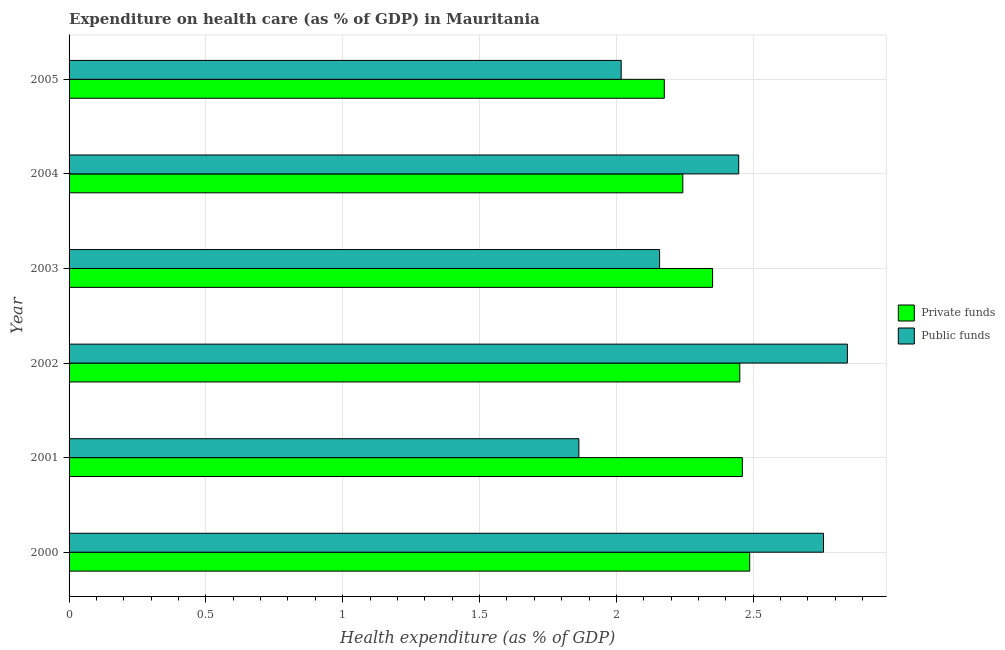How many groups of bars are there?
Your answer should be compact. 6. Are the number of bars per tick equal to the number of legend labels?
Provide a succinct answer. Yes. What is the amount of private funds spent in healthcare in 2003?
Offer a very short reply. 2.35. Across all years, what is the maximum amount of private funds spent in healthcare?
Offer a very short reply. 2.49. Across all years, what is the minimum amount of private funds spent in healthcare?
Your answer should be compact. 2.18. In which year was the amount of private funds spent in healthcare maximum?
Your response must be concise. 2000. What is the total amount of private funds spent in healthcare in the graph?
Your answer should be compact. 14.17. What is the difference between the amount of public funds spent in healthcare in 2000 and that in 2005?
Keep it short and to the point. 0.74. What is the difference between the amount of public funds spent in healthcare in 2004 and the amount of private funds spent in healthcare in 2001?
Provide a short and direct response. -0.01. What is the average amount of public funds spent in healthcare per year?
Offer a terse response. 2.35. In the year 2001, what is the difference between the amount of private funds spent in healthcare and amount of public funds spent in healthcare?
Your answer should be compact. 0.6. What is the ratio of the amount of public funds spent in healthcare in 2001 to that in 2002?
Offer a very short reply. 0.66. Is the amount of private funds spent in healthcare in 2000 less than that in 2001?
Give a very brief answer. No. What is the difference between the highest and the second highest amount of public funds spent in healthcare?
Keep it short and to the point. 0.09. What is the difference between the highest and the lowest amount of private funds spent in healthcare?
Keep it short and to the point. 0.31. In how many years, is the amount of private funds spent in healthcare greater than the average amount of private funds spent in healthcare taken over all years?
Make the answer very short. 3. What does the 2nd bar from the top in 2004 represents?
Provide a short and direct response. Private funds. What does the 1st bar from the bottom in 2000 represents?
Keep it short and to the point. Private funds. How many bars are there?
Offer a very short reply. 12. What is the difference between two consecutive major ticks on the X-axis?
Your answer should be very brief. 0.5. Are the values on the major ticks of X-axis written in scientific E-notation?
Your answer should be compact. No. Where does the legend appear in the graph?
Offer a very short reply. Center right. How many legend labels are there?
Keep it short and to the point. 2. What is the title of the graph?
Make the answer very short. Expenditure on health care (as % of GDP) in Mauritania. What is the label or title of the X-axis?
Keep it short and to the point. Health expenditure (as % of GDP). What is the label or title of the Y-axis?
Your answer should be very brief. Year. What is the Health expenditure (as % of GDP) in Private funds in 2000?
Ensure brevity in your answer.  2.49. What is the Health expenditure (as % of GDP) of Public funds in 2000?
Your response must be concise. 2.76. What is the Health expenditure (as % of GDP) in Private funds in 2001?
Your response must be concise. 2.46. What is the Health expenditure (as % of GDP) of Public funds in 2001?
Keep it short and to the point. 1.86. What is the Health expenditure (as % of GDP) of Private funds in 2002?
Keep it short and to the point. 2.45. What is the Health expenditure (as % of GDP) in Public funds in 2002?
Ensure brevity in your answer.  2.84. What is the Health expenditure (as % of GDP) in Private funds in 2003?
Provide a short and direct response. 2.35. What is the Health expenditure (as % of GDP) of Public funds in 2003?
Your response must be concise. 2.16. What is the Health expenditure (as % of GDP) in Private funds in 2004?
Ensure brevity in your answer.  2.24. What is the Health expenditure (as % of GDP) in Public funds in 2004?
Your answer should be compact. 2.45. What is the Health expenditure (as % of GDP) in Private funds in 2005?
Provide a succinct answer. 2.18. What is the Health expenditure (as % of GDP) in Public funds in 2005?
Make the answer very short. 2.02. Across all years, what is the maximum Health expenditure (as % of GDP) in Private funds?
Keep it short and to the point. 2.49. Across all years, what is the maximum Health expenditure (as % of GDP) of Public funds?
Keep it short and to the point. 2.84. Across all years, what is the minimum Health expenditure (as % of GDP) in Private funds?
Provide a succinct answer. 2.18. Across all years, what is the minimum Health expenditure (as % of GDP) in Public funds?
Provide a succinct answer. 1.86. What is the total Health expenditure (as % of GDP) in Private funds in the graph?
Make the answer very short. 14.17. What is the total Health expenditure (as % of GDP) of Public funds in the graph?
Your response must be concise. 14.09. What is the difference between the Health expenditure (as % of GDP) in Private funds in 2000 and that in 2001?
Your response must be concise. 0.03. What is the difference between the Health expenditure (as % of GDP) in Public funds in 2000 and that in 2001?
Give a very brief answer. 0.89. What is the difference between the Health expenditure (as % of GDP) of Private funds in 2000 and that in 2002?
Your answer should be very brief. 0.04. What is the difference between the Health expenditure (as % of GDP) in Public funds in 2000 and that in 2002?
Ensure brevity in your answer.  -0.09. What is the difference between the Health expenditure (as % of GDP) in Private funds in 2000 and that in 2003?
Ensure brevity in your answer.  0.14. What is the difference between the Health expenditure (as % of GDP) in Public funds in 2000 and that in 2003?
Provide a succinct answer. 0.6. What is the difference between the Health expenditure (as % of GDP) in Private funds in 2000 and that in 2004?
Ensure brevity in your answer.  0.24. What is the difference between the Health expenditure (as % of GDP) in Public funds in 2000 and that in 2004?
Offer a terse response. 0.31. What is the difference between the Health expenditure (as % of GDP) in Private funds in 2000 and that in 2005?
Provide a succinct answer. 0.31. What is the difference between the Health expenditure (as % of GDP) in Public funds in 2000 and that in 2005?
Keep it short and to the point. 0.74. What is the difference between the Health expenditure (as % of GDP) in Private funds in 2001 and that in 2002?
Your answer should be compact. 0.01. What is the difference between the Health expenditure (as % of GDP) of Public funds in 2001 and that in 2002?
Keep it short and to the point. -0.98. What is the difference between the Health expenditure (as % of GDP) of Private funds in 2001 and that in 2003?
Make the answer very short. 0.11. What is the difference between the Health expenditure (as % of GDP) in Public funds in 2001 and that in 2003?
Provide a succinct answer. -0.29. What is the difference between the Health expenditure (as % of GDP) of Private funds in 2001 and that in 2004?
Give a very brief answer. 0.22. What is the difference between the Health expenditure (as % of GDP) of Public funds in 2001 and that in 2004?
Ensure brevity in your answer.  -0.58. What is the difference between the Health expenditure (as % of GDP) in Private funds in 2001 and that in 2005?
Offer a very short reply. 0.29. What is the difference between the Health expenditure (as % of GDP) in Public funds in 2001 and that in 2005?
Give a very brief answer. -0.15. What is the difference between the Health expenditure (as % of GDP) of Private funds in 2002 and that in 2003?
Make the answer very short. 0.1. What is the difference between the Health expenditure (as % of GDP) in Public funds in 2002 and that in 2003?
Your answer should be very brief. 0.69. What is the difference between the Health expenditure (as % of GDP) of Private funds in 2002 and that in 2004?
Offer a terse response. 0.21. What is the difference between the Health expenditure (as % of GDP) of Public funds in 2002 and that in 2004?
Offer a very short reply. 0.4. What is the difference between the Health expenditure (as % of GDP) of Private funds in 2002 and that in 2005?
Keep it short and to the point. 0.28. What is the difference between the Health expenditure (as % of GDP) of Public funds in 2002 and that in 2005?
Make the answer very short. 0.83. What is the difference between the Health expenditure (as % of GDP) of Private funds in 2003 and that in 2004?
Give a very brief answer. 0.11. What is the difference between the Health expenditure (as % of GDP) of Public funds in 2003 and that in 2004?
Offer a very short reply. -0.29. What is the difference between the Health expenditure (as % of GDP) in Private funds in 2003 and that in 2005?
Your answer should be very brief. 0.18. What is the difference between the Health expenditure (as % of GDP) in Public funds in 2003 and that in 2005?
Offer a terse response. 0.14. What is the difference between the Health expenditure (as % of GDP) of Private funds in 2004 and that in 2005?
Make the answer very short. 0.07. What is the difference between the Health expenditure (as % of GDP) in Public funds in 2004 and that in 2005?
Your answer should be very brief. 0.43. What is the difference between the Health expenditure (as % of GDP) of Private funds in 2000 and the Health expenditure (as % of GDP) of Public funds in 2001?
Give a very brief answer. 0.62. What is the difference between the Health expenditure (as % of GDP) of Private funds in 2000 and the Health expenditure (as % of GDP) of Public funds in 2002?
Your answer should be compact. -0.36. What is the difference between the Health expenditure (as % of GDP) in Private funds in 2000 and the Health expenditure (as % of GDP) in Public funds in 2003?
Your answer should be compact. 0.33. What is the difference between the Health expenditure (as % of GDP) of Private funds in 2000 and the Health expenditure (as % of GDP) of Public funds in 2004?
Your answer should be compact. 0.04. What is the difference between the Health expenditure (as % of GDP) in Private funds in 2000 and the Health expenditure (as % of GDP) in Public funds in 2005?
Provide a short and direct response. 0.47. What is the difference between the Health expenditure (as % of GDP) of Private funds in 2001 and the Health expenditure (as % of GDP) of Public funds in 2002?
Your answer should be compact. -0.38. What is the difference between the Health expenditure (as % of GDP) of Private funds in 2001 and the Health expenditure (as % of GDP) of Public funds in 2003?
Your response must be concise. 0.3. What is the difference between the Health expenditure (as % of GDP) of Private funds in 2001 and the Health expenditure (as % of GDP) of Public funds in 2004?
Provide a short and direct response. 0.01. What is the difference between the Health expenditure (as % of GDP) in Private funds in 2001 and the Health expenditure (as % of GDP) in Public funds in 2005?
Give a very brief answer. 0.44. What is the difference between the Health expenditure (as % of GDP) of Private funds in 2002 and the Health expenditure (as % of GDP) of Public funds in 2003?
Ensure brevity in your answer.  0.29. What is the difference between the Health expenditure (as % of GDP) in Private funds in 2002 and the Health expenditure (as % of GDP) in Public funds in 2004?
Ensure brevity in your answer.  0. What is the difference between the Health expenditure (as % of GDP) of Private funds in 2002 and the Health expenditure (as % of GDP) of Public funds in 2005?
Provide a short and direct response. 0.43. What is the difference between the Health expenditure (as % of GDP) of Private funds in 2003 and the Health expenditure (as % of GDP) of Public funds in 2004?
Make the answer very short. -0.1. What is the difference between the Health expenditure (as % of GDP) in Private funds in 2003 and the Health expenditure (as % of GDP) in Public funds in 2005?
Make the answer very short. 0.33. What is the difference between the Health expenditure (as % of GDP) of Private funds in 2004 and the Health expenditure (as % of GDP) of Public funds in 2005?
Ensure brevity in your answer.  0.23. What is the average Health expenditure (as % of GDP) in Private funds per year?
Offer a terse response. 2.36. What is the average Health expenditure (as % of GDP) in Public funds per year?
Keep it short and to the point. 2.35. In the year 2000, what is the difference between the Health expenditure (as % of GDP) of Private funds and Health expenditure (as % of GDP) of Public funds?
Offer a very short reply. -0.27. In the year 2001, what is the difference between the Health expenditure (as % of GDP) of Private funds and Health expenditure (as % of GDP) of Public funds?
Your answer should be very brief. 0.6. In the year 2002, what is the difference between the Health expenditure (as % of GDP) of Private funds and Health expenditure (as % of GDP) of Public funds?
Provide a succinct answer. -0.39. In the year 2003, what is the difference between the Health expenditure (as % of GDP) of Private funds and Health expenditure (as % of GDP) of Public funds?
Make the answer very short. 0.19. In the year 2004, what is the difference between the Health expenditure (as % of GDP) in Private funds and Health expenditure (as % of GDP) in Public funds?
Ensure brevity in your answer.  -0.2. In the year 2005, what is the difference between the Health expenditure (as % of GDP) of Private funds and Health expenditure (as % of GDP) of Public funds?
Offer a very short reply. 0.16. What is the ratio of the Health expenditure (as % of GDP) in Private funds in 2000 to that in 2001?
Your answer should be compact. 1.01. What is the ratio of the Health expenditure (as % of GDP) in Public funds in 2000 to that in 2001?
Make the answer very short. 1.48. What is the ratio of the Health expenditure (as % of GDP) of Private funds in 2000 to that in 2002?
Your response must be concise. 1.01. What is the ratio of the Health expenditure (as % of GDP) in Public funds in 2000 to that in 2002?
Provide a short and direct response. 0.97. What is the ratio of the Health expenditure (as % of GDP) of Private funds in 2000 to that in 2003?
Your answer should be compact. 1.06. What is the ratio of the Health expenditure (as % of GDP) in Public funds in 2000 to that in 2003?
Your answer should be compact. 1.28. What is the ratio of the Health expenditure (as % of GDP) in Private funds in 2000 to that in 2004?
Ensure brevity in your answer.  1.11. What is the ratio of the Health expenditure (as % of GDP) in Public funds in 2000 to that in 2004?
Your response must be concise. 1.13. What is the ratio of the Health expenditure (as % of GDP) of Private funds in 2000 to that in 2005?
Ensure brevity in your answer.  1.14. What is the ratio of the Health expenditure (as % of GDP) in Public funds in 2000 to that in 2005?
Make the answer very short. 1.37. What is the ratio of the Health expenditure (as % of GDP) of Private funds in 2001 to that in 2002?
Provide a short and direct response. 1. What is the ratio of the Health expenditure (as % of GDP) of Public funds in 2001 to that in 2002?
Keep it short and to the point. 0.66. What is the ratio of the Health expenditure (as % of GDP) of Private funds in 2001 to that in 2003?
Provide a succinct answer. 1.05. What is the ratio of the Health expenditure (as % of GDP) in Public funds in 2001 to that in 2003?
Provide a succinct answer. 0.86. What is the ratio of the Health expenditure (as % of GDP) in Private funds in 2001 to that in 2004?
Your answer should be very brief. 1.1. What is the ratio of the Health expenditure (as % of GDP) in Public funds in 2001 to that in 2004?
Offer a terse response. 0.76. What is the ratio of the Health expenditure (as % of GDP) in Private funds in 2001 to that in 2005?
Your response must be concise. 1.13. What is the ratio of the Health expenditure (as % of GDP) in Public funds in 2001 to that in 2005?
Give a very brief answer. 0.92. What is the ratio of the Health expenditure (as % of GDP) of Private funds in 2002 to that in 2003?
Offer a terse response. 1.04. What is the ratio of the Health expenditure (as % of GDP) in Public funds in 2002 to that in 2003?
Offer a terse response. 1.32. What is the ratio of the Health expenditure (as % of GDP) of Private funds in 2002 to that in 2004?
Your answer should be compact. 1.09. What is the ratio of the Health expenditure (as % of GDP) of Public funds in 2002 to that in 2004?
Your answer should be very brief. 1.16. What is the ratio of the Health expenditure (as % of GDP) of Private funds in 2002 to that in 2005?
Keep it short and to the point. 1.13. What is the ratio of the Health expenditure (as % of GDP) of Public funds in 2002 to that in 2005?
Your answer should be compact. 1.41. What is the ratio of the Health expenditure (as % of GDP) of Private funds in 2003 to that in 2004?
Offer a very short reply. 1.05. What is the ratio of the Health expenditure (as % of GDP) of Public funds in 2003 to that in 2004?
Your answer should be very brief. 0.88. What is the ratio of the Health expenditure (as % of GDP) of Private funds in 2003 to that in 2005?
Make the answer very short. 1.08. What is the ratio of the Health expenditure (as % of GDP) of Public funds in 2003 to that in 2005?
Offer a very short reply. 1.07. What is the ratio of the Health expenditure (as % of GDP) of Private funds in 2004 to that in 2005?
Ensure brevity in your answer.  1.03. What is the ratio of the Health expenditure (as % of GDP) of Public funds in 2004 to that in 2005?
Your response must be concise. 1.21. What is the difference between the highest and the second highest Health expenditure (as % of GDP) of Private funds?
Offer a very short reply. 0.03. What is the difference between the highest and the second highest Health expenditure (as % of GDP) in Public funds?
Make the answer very short. 0.09. What is the difference between the highest and the lowest Health expenditure (as % of GDP) of Private funds?
Keep it short and to the point. 0.31. What is the difference between the highest and the lowest Health expenditure (as % of GDP) of Public funds?
Your answer should be compact. 0.98. 